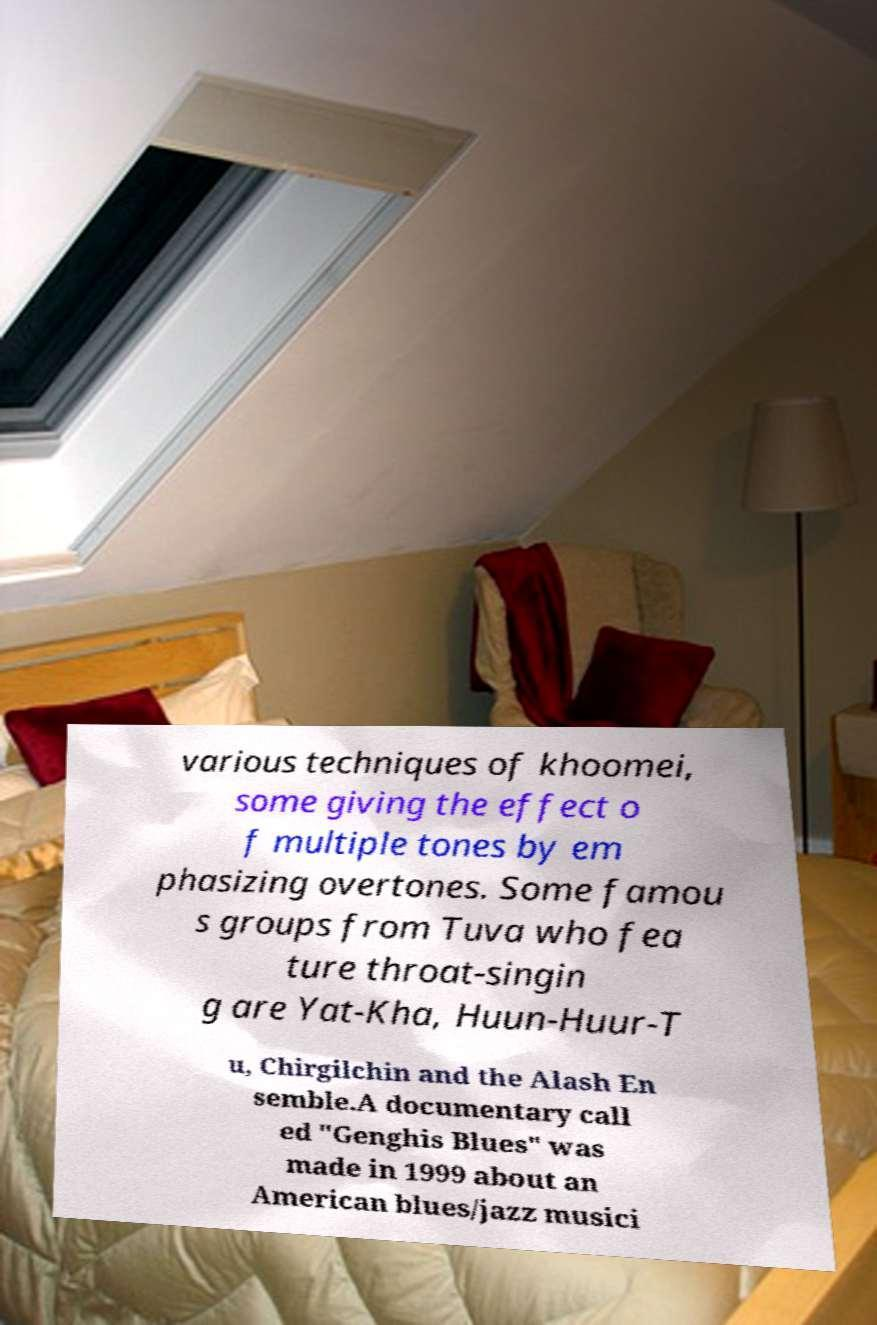Can you read and provide the text displayed in the image?This photo seems to have some interesting text. Can you extract and type it out for me? various techniques of khoomei, some giving the effect o f multiple tones by em phasizing overtones. Some famou s groups from Tuva who fea ture throat-singin g are Yat-Kha, Huun-Huur-T u, Chirgilchin and the Alash En semble.A documentary call ed "Genghis Blues" was made in 1999 about an American blues/jazz musici 